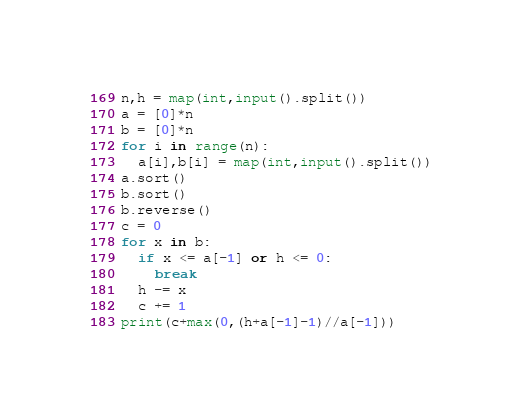<code> <loc_0><loc_0><loc_500><loc_500><_Python_>n,h = map(int,input().split())
a = [0]*n
b = [0]*n
for i in range(n):
  a[i],b[i] = map(int,input().split())
a.sort()
b.sort()
b.reverse()
c = 0
for x in b:
  if x <= a[-1] or h <= 0:
    break
  h -= x
  c += 1
print(c+max(0,(h+a[-1]-1)//a[-1]))</code> 